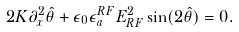<formula> <loc_0><loc_0><loc_500><loc_500>2 K \partial _ { x } ^ { 2 } \hat { \theta } + \epsilon _ { 0 } \epsilon ^ { R F } _ { a } E _ { R F } ^ { 2 } \sin ( 2 \hat { \theta } ) = 0 .</formula> 